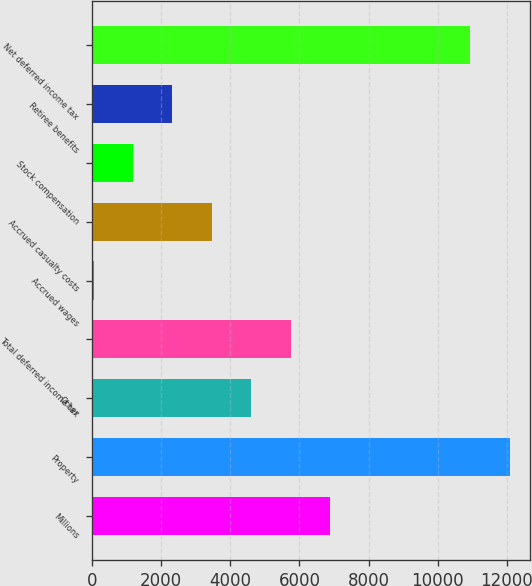<chart> <loc_0><loc_0><loc_500><loc_500><bar_chart><fcel>Millions<fcel>Property<fcel>Other<fcel>Total deferred income tax<fcel>Accrued wages<fcel>Accrued casualty costs<fcel>Stock compensation<fcel>Retiree benefits<fcel>Net deferred income tax<nl><fcel>6893.8<fcel>12077.3<fcel>4611.2<fcel>5752.5<fcel>46<fcel>3469.9<fcel>1187.3<fcel>2328.6<fcel>10936<nl></chart> 